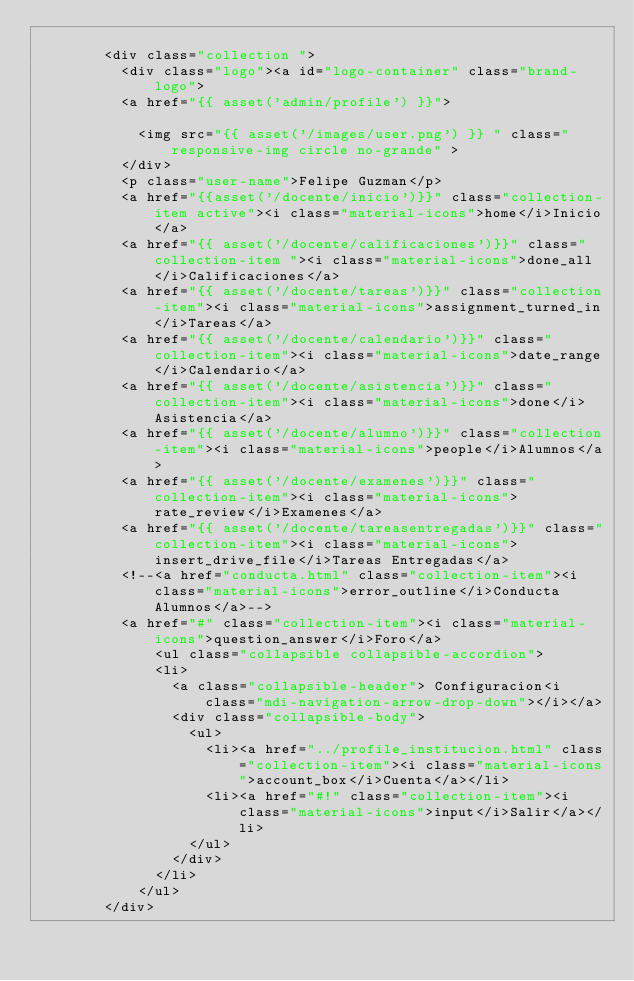<code> <loc_0><loc_0><loc_500><loc_500><_PHP_>
        <div class="collection ">
          <div class="logo"><a id="logo-container" class="brand-logo">
          <a href="{{ asset('admin/profile') }}">
    
            <img src="{{ asset('/images/user.png') }} " class="responsive-img circle no-grande" >
          </div>
          <p class="user-name">Felipe Guzman</p>
          <a href="{{asset('/docente/inicio')}}" class="collection-item active"><i class="material-icons">home</i>Inicio</a>
          <a href="{{ asset('/docente/calificaciones')}}" class="collection-item "><i class="material-icons">done_all</i>Calificaciones</a>
          <a href="{{ asset('/docente/tareas')}}" class="collection-item"><i class="material-icons">assignment_turned_in</i>Tareas</a>
          <a href="{{ asset('/docente/calendario')}}" class="collection-item"><i class="material-icons">date_range</i>Calendario</a>
          <a href="{{ asset('/docente/asistencia')}}" class="collection-item"><i class="material-icons">done</i>Asistencia</a>
          <a href="{{ asset('/docente/alumno')}}" class="collection-item"><i class="material-icons">people</i>Alumnos</a>
          <a href="{{ asset('/docente/examenes')}}" class="collection-item"><i class="material-icons">rate_review</i>Examenes</a>
          <a href="{{ asset('/docente/tareasentregadas')}}" class="collection-item"><i class="material-icons">insert_drive_file</i>Tareas Entregadas</a>
          <!--<a href="conducta.html" class="collection-item"><i class="material-icons">error_outline</i>Conducta Alumnos</a>-->
          <a href="#" class="collection-item"><i class="material-icons">question_answer</i>Foro</a>
              <ul class="collapsible collapsible-accordion">
              <li>
                <a class="collapsible-header"> Configuracion<i class="mdi-navigation-arrow-drop-down"></i></a>
                <div class="collapsible-body">
                  <ul>
                    <li><a href="../profile_institucion.html" class="collection-item"><i class="material-icons">account_box</i>Cuenta</a></li>
                    <li><a href="#!" class="collection-item"><i class="material-icons">input</i>Salir</a></li>
                  </ul>
                </div>
              </li>
            </ul>
        </div></code> 